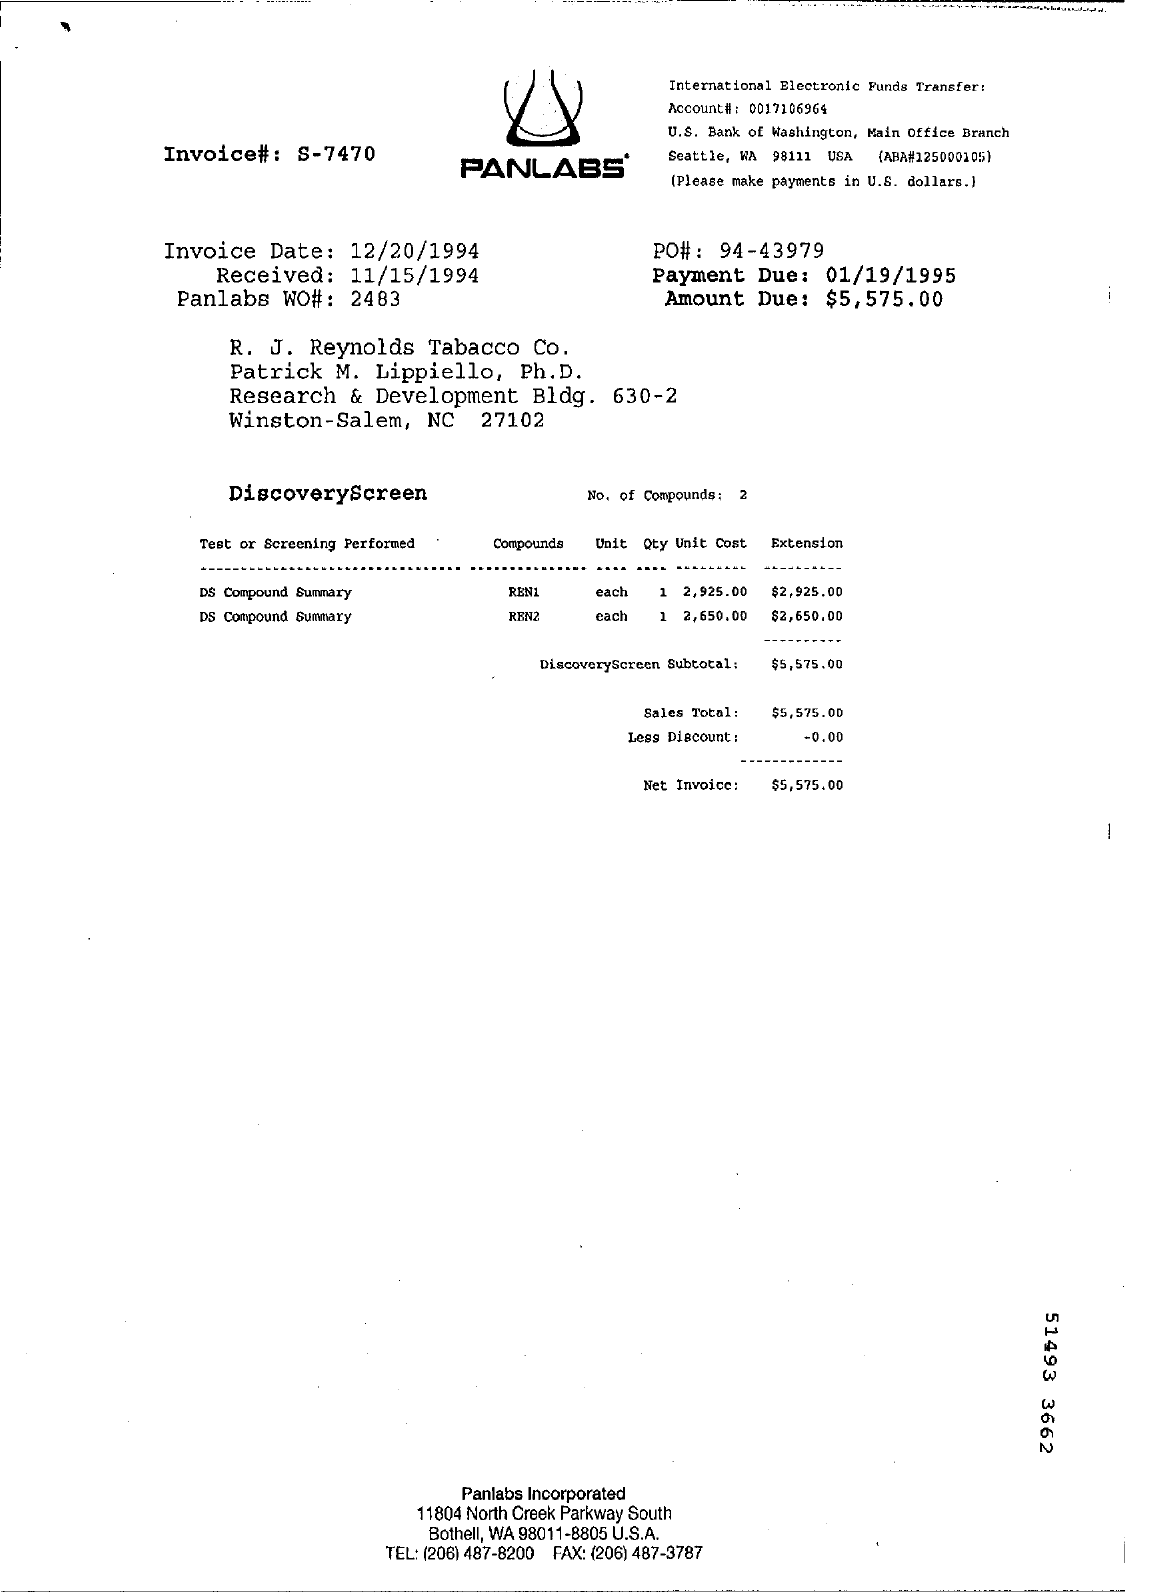Mention a couple of crucial points in this snapshot. The amount due is $5,575.00. The invoice date is December 20, 1994. The payment due date is January 19, 1995. The laboratory written on top is called PANLABS. 